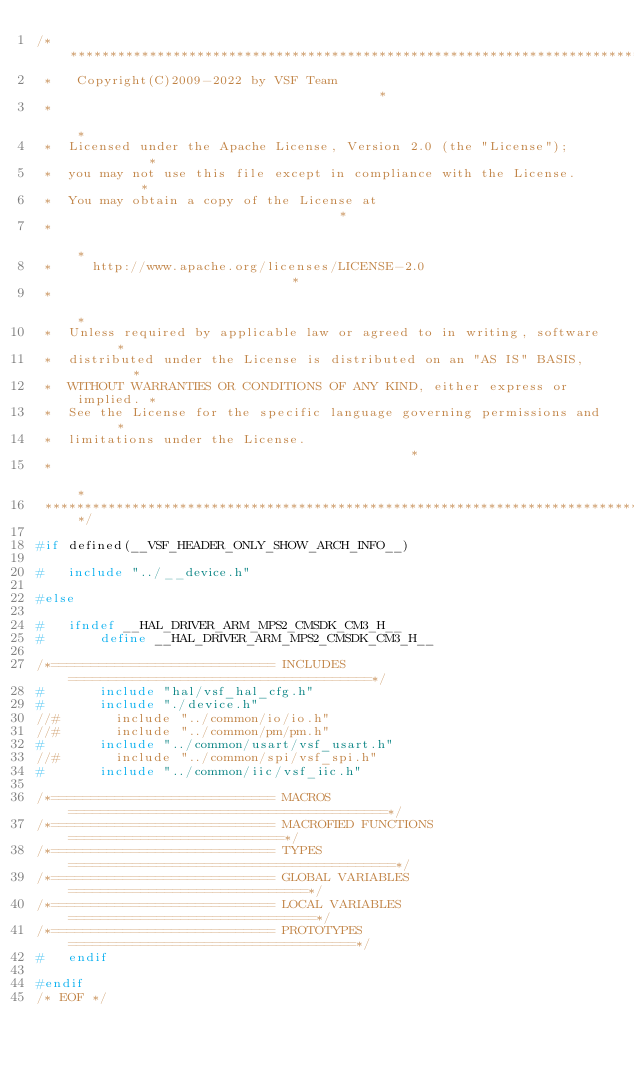Convert code to text. <code><loc_0><loc_0><loc_500><loc_500><_C_>/*****************************************************************************
 *   Copyright(C)2009-2022 by VSF Team                                       *
 *                                                                           *
 *  Licensed under the Apache License, Version 2.0 (the "License");          *
 *  you may not use this file except in compliance with the License.         *
 *  You may obtain a copy of the License at                                  *
 *                                                                           *
 *     http://www.apache.org/licenses/LICENSE-2.0                            *
 *                                                                           *
 *  Unless required by applicable law or agreed to in writing, software      *
 *  distributed under the License is distributed on an "AS IS" BASIS,        *
 *  WITHOUT WARRANTIES OR CONDITIONS OF ANY KIND, either express or implied. *
 *  See the License for the specific language governing permissions and      *
 *  limitations under the License.                                           *
 *                                                                           *
 ****************************************************************************/

#if defined(__VSF_HEADER_ONLY_SHOW_ARCH_INFO__)

#   include "../__device.h"

#else

#   ifndef __HAL_DRIVER_ARM_MPS2_CMSDK_CM3_H__
#       define __HAL_DRIVER_ARM_MPS2_CMSDK_CM3_H__

/*============================ INCLUDES ======================================*/
#       include "hal/vsf_hal_cfg.h"   
#       include "./device.h"
//#       include "../common/io/io.h"
//#       include "../common/pm/pm.h"
#       include "../common/usart/vsf_usart.h"
//#       include "../common/spi/vsf_spi.h"
#       include "../common/iic/vsf_iic.h"

/*============================ MACROS ========================================*/
/*============================ MACROFIED FUNCTIONS ===========================*/
/*============================ TYPES =========================================*/
/*============================ GLOBAL VARIABLES ==============================*/
/*============================ LOCAL VARIABLES ===============================*/
/*============================ PROTOTYPES ====================================*/
#   endif

#endif
/* EOF */
</code> 